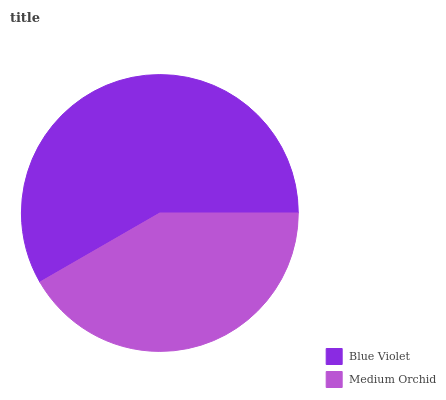Is Medium Orchid the minimum?
Answer yes or no. Yes. Is Blue Violet the maximum?
Answer yes or no. Yes. Is Medium Orchid the maximum?
Answer yes or no. No. Is Blue Violet greater than Medium Orchid?
Answer yes or no. Yes. Is Medium Orchid less than Blue Violet?
Answer yes or no. Yes. Is Medium Orchid greater than Blue Violet?
Answer yes or no. No. Is Blue Violet less than Medium Orchid?
Answer yes or no. No. Is Blue Violet the high median?
Answer yes or no. Yes. Is Medium Orchid the low median?
Answer yes or no. Yes. Is Medium Orchid the high median?
Answer yes or no. No. Is Blue Violet the low median?
Answer yes or no. No. 